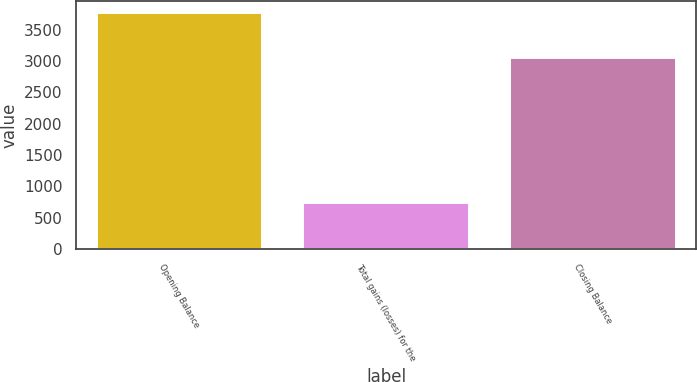Convert chart. <chart><loc_0><loc_0><loc_500><loc_500><bar_chart><fcel>Opening Balance<fcel>Total gains (losses) for the<fcel>Closing Balance<nl><fcel>3768<fcel>727<fcel>3041<nl></chart> 